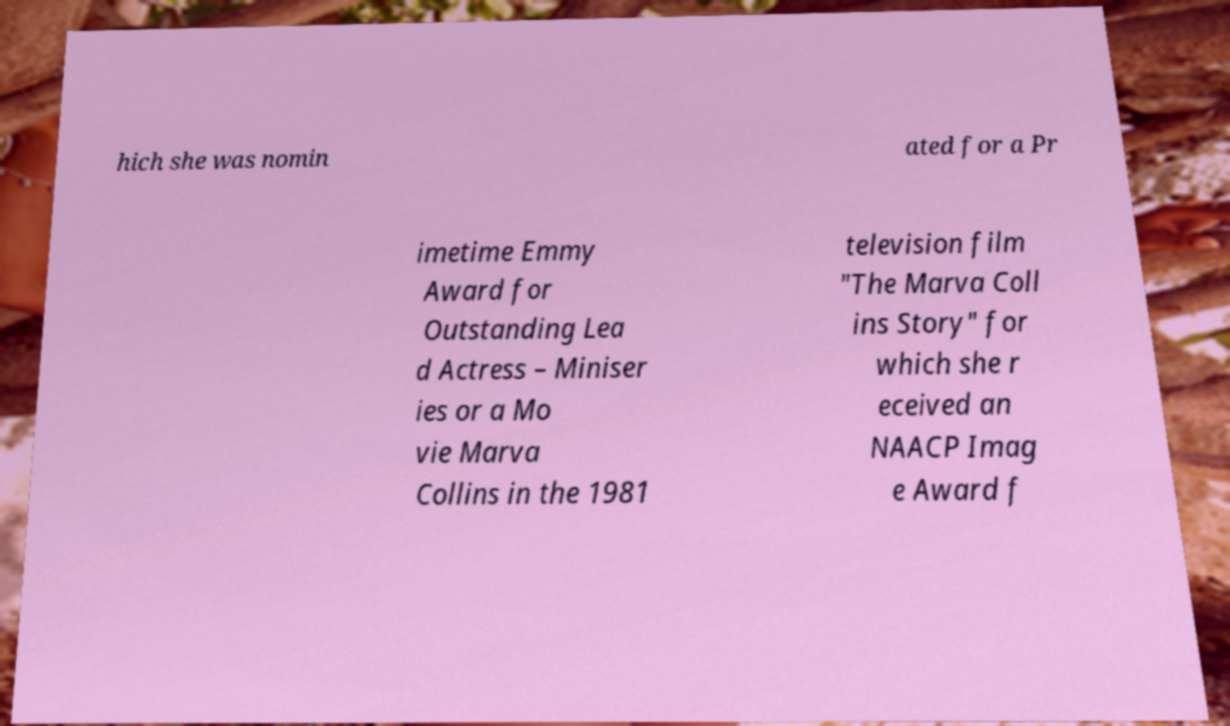Can you read and provide the text displayed in the image?This photo seems to have some interesting text. Can you extract and type it out for me? hich she was nomin ated for a Pr imetime Emmy Award for Outstanding Lea d Actress – Miniser ies or a Mo vie Marva Collins in the 1981 television film "The Marva Coll ins Story" for which she r eceived an NAACP Imag e Award f 